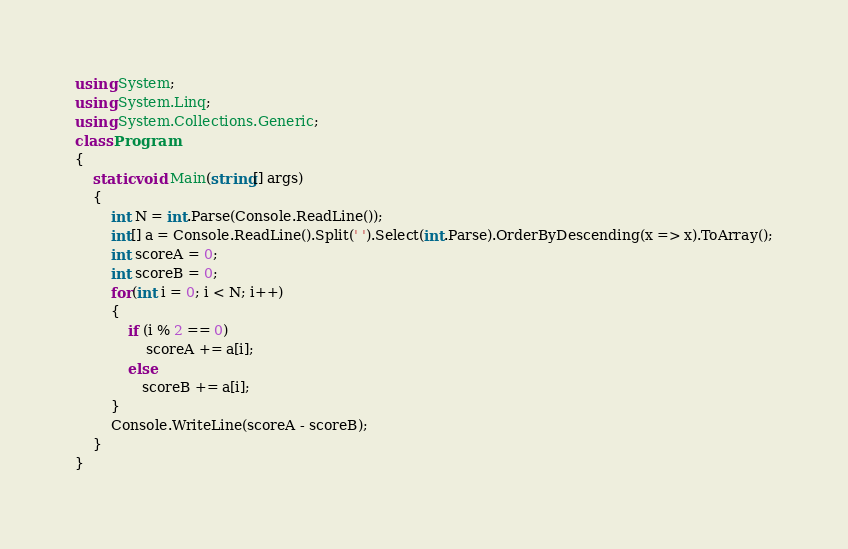<code> <loc_0><loc_0><loc_500><loc_500><_C#_>using System;
using System.Linq;
using System.Collections.Generic;
class Program
{
    static void Main(string[] args)
    {
        int N = int.Parse(Console.ReadLine());
        int[] a = Console.ReadLine().Split(' ').Select(int.Parse).OrderByDescending(x => x).ToArray();
        int scoreA = 0;
        int scoreB = 0;
        for(int i = 0; i < N; i++)
        {
            if (i % 2 == 0)
                scoreA += a[i];
            else
               scoreB += a[i];
        }
        Console.WriteLine(scoreA - scoreB);
    }
}
</code> 